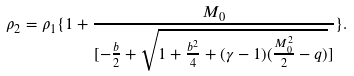<formula> <loc_0><loc_0><loc_500><loc_500>\rho _ { 2 } = \rho _ { 1 } \{ 1 + \frac { M _ { 0 } } { [ - \frac { b } { 2 } + \sqrt { 1 + \frac { b ^ { 2 } } { 4 } + ( \gamma - 1 ) ( \frac { M _ { 0 } ^ { 2 } } { 2 } - q ) } ] } \} .</formula> 